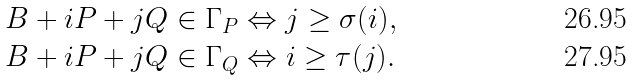Convert formula to latex. <formula><loc_0><loc_0><loc_500><loc_500>& B + i P + j Q \in \Gamma _ { P } \Leftrightarrow j \geq \sigma ( i ) , \\ & B + i P + j Q \in \Gamma _ { Q } \Leftrightarrow i \geq \tau ( j ) .</formula> 